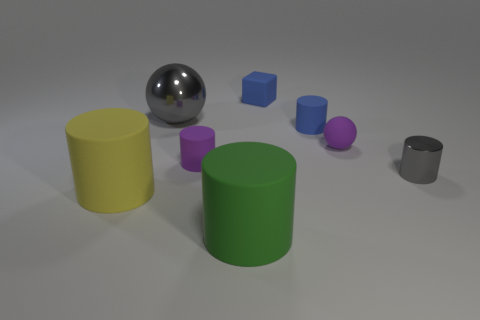What is the shape of the object that is behind the tiny blue rubber cylinder and right of the big metallic sphere?
Keep it short and to the point. Cube. Are there any other rubber objects of the same size as the green thing?
Give a very brief answer. Yes. Is the shape of the big rubber thing that is in front of the large yellow cylinder the same as  the small gray shiny object?
Your answer should be compact. Yes. Is the large green matte object the same shape as the yellow object?
Your answer should be compact. Yes. Is there a purple matte thing of the same shape as the green object?
Offer a terse response. Yes. What shape is the large thing behind the tiny rubber object on the left side of the tiny cube?
Provide a short and direct response. Sphere. What color is the large cylinder that is to the right of the large yellow rubber thing?
Your answer should be very brief. Green. There is a blue object that is made of the same material as the blue cylinder; what size is it?
Keep it short and to the point. Small. There is a purple rubber thing that is the same shape as the big metal object; what size is it?
Provide a succinct answer. Small. Are any red matte blocks visible?
Offer a very short reply. No. 